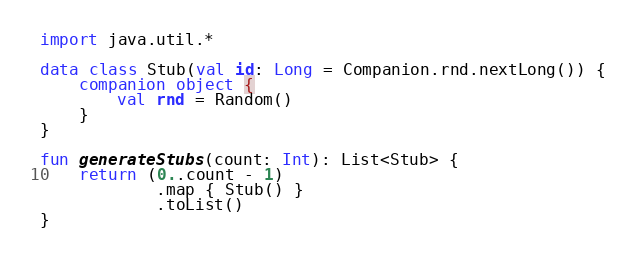<code> <loc_0><loc_0><loc_500><loc_500><_Kotlin_>
import java.util.*

data class Stub(val id: Long = Companion.rnd.nextLong()) {
    companion object {
        val rnd = Random()
    }
}

fun generateStubs(count: Int): List<Stub> {
    return (0..count - 1)
            .map { Stub() }
            .toList()
}

</code> 